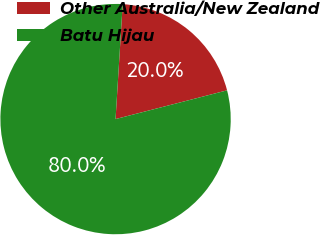Convert chart. <chart><loc_0><loc_0><loc_500><loc_500><pie_chart><fcel>Other Australia/New Zealand<fcel>Batu Hijau<nl><fcel>20.0%<fcel>80.0%<nl></chart> 